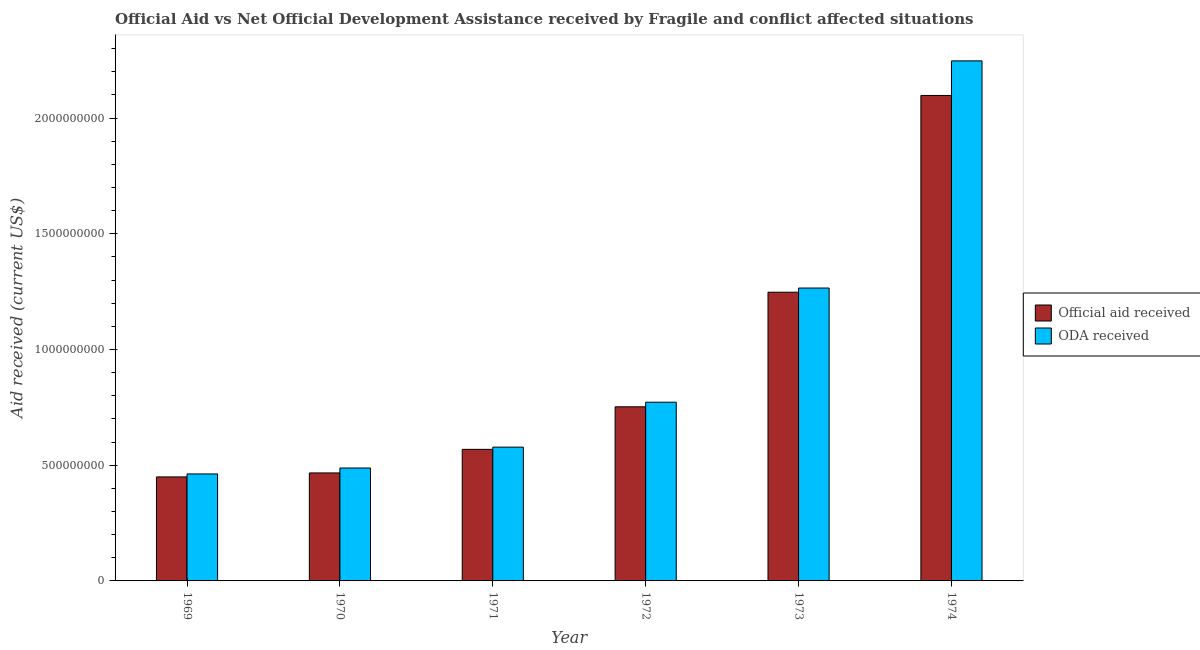Are the number of bars on each tick of the X-axis equal?
Offer a very short reply. Yes. How many bars are there on the 2nd tick from the left?
Make the answer very short. 2. What is the oda received in 1972?
Offer a very short reply. 7.72e+08. Across all years, what is the maximum oda received?
Ensure brevity in your answer.  2.25e+09. Across all years, what is the minimum official aid received?
Provide a succinct answer. 4.49e+08. In which year was the official aid received maximum?
Your response must be concise. 1974. In which year was the oda received minimum?
Offer a very short reply. 1969. What is the total oda received in the graph?
Give a very brief answer. 5.81e+09. What is the difference between the official aid received in 1969 and that in 1973?
Your response must be concise. -7.98e+08. What is the difference between the oda received in 1971 and the official aid received in 1972?
Your response must be concise. -1.94e+08. What is the average oda received per year?
Keep it short and to the point. 9.69e+08. In the year 1973, what is the difference between the official aid received and oda received?
Offer a terse response. 0. In how many years, is the oda received greater than 800000000 US$?
Provide a short and direct response. 2. What is the ratio of the oda received in 1969 to that in 1974?
Your response must be concise. 0.21. Is the official aid received in 1969 less than that in 1973?
Provide a short and direct response. Yes. Is the difference between the official aid received in 1970 and 1971 greater than the difference between the oda received in 1970 and 1971?
Provide a short and direct response. No. What is the difference between the highest and the second highest oda received?
Your response must be concise. 9.81e+08. What is the difference between the highest and the lowest official aid received?
Provide a succinct answer. 1.65e+09. Is the sum of the oda received in 1971 and 1973 greater than the maximum official aid received across all years?
Make the answer very short. No. What does the 1st bar from the left in 1974 represents?
Your answer should be compact. Official aid received. What does the 2nd bar from the right in 1969 represents?
Offer a terse response. Official aid received. Are all the bars in the graph horizontal?
Ensure brevity in your answer.  No. What is the difference between two consecutive major ticks on the Y-axis?
Offer a very short reply. 5.00e+08. Does the graph contain any zero values?
Keep it short and to the point. No. Does the graph contain grids?
Ensure brevity in your answer.  No. How are the legend labels stacked?
Your response must be concise. Vertical. What is the title of the graph?
Your answer should be compact. Official Aid vs Net Official Development Assistance received by Fragile and conflict affected situations . What is the label or title of the X-axis?
Make the answer very short. Year. What is the label or title of the Y-axis?
Offer a very short reply. Aid received (current US$). What is the Aid received (current US$) in Official aid received in 1969?
Offer a terse response. 4.49e+08. What is the Aid received (current US$) of ODA received in 1969?
Provide a succinct answer. 4.62e+08. What is the Aid received (current US$) of Official aid received in 1970?
Offer a very short reply. 4.67e+08. What is the Aid received (current US$) of ODA received in 1970?
Ensure brevity in your answer.  4.88e+08. What is the Aid received (current US$) of Official aid received in 1971?
Give a very brief answer. 5.68e+08. What is the Aid received (current US$) in ODA received in 1971?
Offer a terse response. 5.78e+08. What is the Aid received (current US$) in Official aid received in 1972?
Keep it short and to the point. 7.52e+08. What is the Aid received (current US$) of ODA received in 1972?
Your answer should be very brief. 7.72e+08. What is the Aid received (current US$) of Official aid received in 1973?
Keep it short and to the point. 1.25e+09. What is the Aid received (current US$) of ODA received in 1973?
Provide a short and direct response. 1.27e+09. What is the Aid received (current US$) of Official aid received in 1974?
Provide a succinct answer. 2.10e+09. What is the Aid received (current US$) in ODA received in 1974?
Your answer should be very brief. 2.25e+09. Across all years, what is the maximum Aid received (current US$) of Official aid received?
Give a very brief answer. 2.10e+09. Across all years, what is the maximum Aid received (current US$) in ODA received?
Ensure brevity in your answer.  2.25e+09. Across all years, what is the minimum Aid received (current US$) in Official aid received?
Give a very brief answer. 4.49e+08. Across all years, what is the minimum Aid received (current US$) in ODA received?
Provide a succinct answer. 4.62e+08. What is the total Aid received (current US$) in Official aid received in the graph?
Ensure brevity in your answer.  5.58e+09. What is the total Aid received (current US$) in ODA received in the graph?
Your answer should be very brief. 5.81e+09. What is the difference between the Aid received (current US$) in Official aid received in 1969 and that in 1970?
Your response must be concise. -1.72e+07. What is the difference between the Aid received (current US$) in ODA received in 1969 and that in 1970?
Your answer should be very brief. -2.56e+07. What is the difference between the Aid received (current US$) in Official aid received in 1969 and that in 1971?
Offer a terse response. -1.19e+08. What is the difference between the Aid received (current US$) of ODA received in 1969 and that in 1971?
Your answer should be compact. -1.16e+08. What is the difference between the Aid received (current US$) in Official aid received in 1969 and that in 1972?
Your response must be concise. -3.03e+08. What is the difference between the Aid received (current US$) of ODA received in 1969 and that in 1972?
Make the answer very short. -3.10e+08. What is the difference between the Aid received (current US$) of Official aid received in 1969 and that in 1973?
Offer a terse response. -7.98e+08. What is the difference between the Aid received (current US$) in ODA received in 1969 and that in 1973?
Give a very brief answer. -8.03e+08. What is the difference between the Aid received (current US$) in Official aid received in 1969 and that in 1974?
Make the answer very short. -1.65e+09. What is the difference between the Aid received (current US$) in ODA received in 1969 and that in 1974?
Make the answer very short. -1.78e+09. What is the difference between the Aid received (current US$) of Official aid received in 1970 and that in 1971?
Offer a terse response. -1.02e+08. What is the difference between the Aid received (current US$) of ODA received in 1970 and that in 1971?
Your answer should be compact. -9.02e+07. What is the difference between the Aid received (current US$) of Official aid received in 1970 and that in 1972?
Your answer should be compact. -2.86e+08. What is the difference between the Aid received (current US$) in ODA received in 1970 and that in 1972?
Your answer should be very brief. -2.84e+08. What is the difference between the Aid received (current US$) in Official aid received in 1970 and that in 1973?
Offer a terse response. -7.81e+08. What is the difference between the Aid received (current US$) in ODA received in 1970 and that in 1973?
Your answer should be compact. -7.78e+08. What is the difference between the Aid received (current US$) of Official aid received in 1970 and that in 1974?
Your answer should be compact. -1.63e+09. What is the difference between the Aid received (current US$) in ODA received in 1970 and that in 1974?
Provide a short and direct response. -1.76e+09. What is the difference between the Aid received (current US$) of Official aid received in 1971 and that in 1972?
Give a very brief answer. -1.84e+08. What is the difference between the Aid received (current US$) of ODA received in 1971 and that in 1972?
Make the answer very short. -1.94e+08. What is the difference between the Aid received (current US$) in Official aid received in 1971 and that in 1973?
Give a very brief answer. -6.79e+08. What is the difference between the Aid received (current US$) in ODA received in 1971 and that in 1973?
Your answer should be very brief. -6.87e+08. What is the difference between the Aid received (current US$) in Official aid received in 1971 and that in 1974?
Your answer should be very brief. -1.53e+09. What is the difference between the Aid received (current US$) of ODA received in 1971 and that in 1974?
Ensure brevity in your answer.  -1.67e+09. What is the difference between the Aid received (current US$) in Official aid received in 1972 and that in 1973?
Ensure brevity in your answer.  -4.95e+08. What is the difference between the Aid received (current US$) of ODA received in 1972 and that in 1973?
Your answer should be very brief. -4.93e+08. What is the difference between the Aid received (current US$) in Official aid received in 1972 and that in 1974?
Keep it short and to the point. -1.35e+09. What is the difference between the Aid received (current US$) of ODA received in 1972 and that in 1974?
Offer a terse response. -1.47e+09. What is the difference between the Aid received (current US$) of Official aid received in 1973 and that in 1974?
Provide a succinct answer. -8.50e+08. What is the difference between the Aid received (current US$) in ODA received in 1973 and that in 1974?
Keep it short and to the point. -9.81e+08. What is the difference between the Aid received (current US$) of Official aid received in 1969 and the Aid received (current US$) of ODA received in 1970?
Offer a very short reply. -3.85e+07. What is the difference between the Aid received (current US$) of Official aid received in 1969 and the Aid received (current US$) of ODA received in 1971?
Offer a very short reply. -1.29e+08. What is the difference between the Aid received (current US$) of Official aid received in 1969 and the Aid received (current US$) of ODA received in 1972?
Provide a succinct answer. -3.23e+08. What is the difference between the Aid received (current US$) in Official aid received in 1969 and the Aid received (current US$) in ODA received in 1973?
Make the answer very short. -8.16e+08. What is the difference between the Aid received (current US$) in Official aid received in 1969 and the Aid received (current US$) in ODA received in 1974?
Ensure brevity in your answer.  -1.80e+09. What is the difference between the Aid received (current US$) of Official aid received in 1970 and the Aid received (current US$) of ODA received in 1971?
Offer a very short reply. -1.11e+08. What is the difference between the Aid received (current US$) of Official aid received in 1970 and the Aid received (current US$) of ODA received in 1972?
Ensure brevity in your answer.  -3.06e+08. What is the difference between the Aid received (current US$) in Official aid received in 1970 and the Aid received (current US$) in ODA received in 1973?
Ensure brevity in your answer.  -7.99e+08. What is the difference between the Aid received (current US$) in Official aid received in 1970 and the Aid received (current US$) in ODA received in 1974?
Your answer should be very brief. -1.78e+09. What is the difference between the Aid received (current US$) of Official aid received in 1971 and the Aid received (current US$) of ODA received in 1972?
Your answer should be compact. -2.04e+08. What is the difference between the Aid received (current US$) of Official aid received in 1971 and the Aid received (current US$) of ODA received in 1973?
Give a very brief answer. -6.97e+08. What is the difference between the Aid received (current US$) in Official aid received in 1971 and the Aid received (current US$) in ODA received in 1974?
Offer a terse response. -1.68e+09. What is the difference between the Aid received (current US$) of Official aid received in 1972 and the Aid received (current US$) of ODA received in 1973?
Offer a very short reply. -5.13e+08. What is the difference between the Aid received (current US$) of Official aid received in 1972 and the Aid received (current US$) of ODA received in 1974?
Your answer should be very brief. -1.49e+09. What is the difference between the Aid received (current US$) in Official aid received in 1973 and the Aid received (current US$) in ODA received in 1974?
Keep it short and to the point. -9.99e+08. What is the average Aid received (current US$) of Official aid received per year?
Give a very brief answer. 9.30e+08. What is the average Aid received (current US$) of ODA received per year?
Your response must be concise. 9.69e+08. In the year 1969, what is the difference between the Aid received (current US$) of Official aid received and Aid received (current US$) of ODA received?
Ensure brevity in your answer.  -1.29e+07. In the year 1970, what is the difference between the Aid received (current US$) in Official aid received and Aid received (current US$) in ODA received?
Give a very brief answer. -2.13e+07. In the year 1971, what is the difference between the Aid received (current US$) in Official aid received and Aid received (current US$) in ODA received?
Give a very brief answer. -9.60e+06. In the year 1972, what is the difference between the Aid received (current US$) in Official aid received and Aid received (current US$) in ODA received?
Your answer should be very brief. -1.99e+07. In the year 1973, what is the difference between the Aid received (current US$) of Official aid received and Aid received (current US$) of ODA received?
Your response must be concise. -1.81e+07. In the year 1974, what is the difference between the Aid received (current US$) of Official aid received and Aid received (current US$) of ODA received?
Offer a terse response. -1.49e+08. What is the ratio of the Aid received (current US$) of Official aid received in 1969 to that in 1970?
Ensure brevity in your answer.  0.96. What is the ratio of the Aid received (current US$) of ODA received in 1969 to that in 1970?
Give a very brief answer. 0.95. What is the ratio of the Aid received (current US$) of Official aid received in 1969 to that in 1971?
Offer a terse response. 0.79. What is the ratio of the Aid received (current US$) in ODA received in 1969 to that in 1971?
Your answer should be very brief. 0.8. What is the ratio of the Aid received (current US$) in Official aid received in 1969 to that in 1972?
Your answer should be very brief. 0.6. What is the ratio of the Aid received (current US$) in ODA received in 1969 to that in 1972?
Your response must be concise. 0.6. What is the ratio of the Aid received (current US$) of Official aid received in 1969 to that in 1973?
Offer a very short reply. 0.36. What is the ratio of the Aid received (current US$) in ODA received in 1969 to that in 1973?
Your answer should be very brief. 0.37. What is the ratio of the Aid received (current US$) in Official aid received in 1969 to that in 1974?
Give a very brief answer. 0.21. What is the ratio of the Aid received (current US$) of ODA received in 1969 to that in 1974?
Keep it short and to the point. 0.21. What is the ratio of the Aid received (current US$) in Official aid received in 1970 to that in 1971?
Offer a very short reply. 0.82. What is the ratio of the Aid received (current US$) of ODA received in 1970 to that in 1971?
Provide a succinct answer. 0.84. What is the ratio of the Aid received (current US$) of Official aid received in 1970 to that in 1972?
Your answer should be compact. 0.62. What is the ratio of the Aid received (current US$) in ODA received in 1970 to that in 1972?
Offer a very short reply. 0.63. What is the ratio of the Aid received (current US$) of Official aid received in 1970 to that in 1973?
Give a very brief answer. 0.37. What is the ratio of the Aid received (current US$) of ODA received in 1970 to that in 1973?
Your answer should be very brief. 0.39. What is the ratio of the Aid received (current US$) of Official aid received in 1970 to that in 1974?
Offer a terse response. 0.22. What is the ratio of the Aid received (current US$) in ODA received in 1970 to that in 1974?
Keep it short and to the point. 0.22. What is the ratio of the Aid received (current US$) in Official aid received in 1971 to that in 1972?
Provide a short and direct response. 0.76. What is the ratio of the Aid received (current US$) in ODA received in 1971 to that in 1972?
Your answer should be compact. 0.75. What is the ratio of the Aid received (current US$) in Official aid received in 1971 to that in 1973?
Give a very brief answer. 0.46. What is the ratio of the Aid received (current US$) of ODA received in 1971 to that in 1973?
Your answer should be very brief. 0.46. What is the ratio of the Aid received (current US$) in Official aid received in 1971 to that in 1974?
Keep it short and to the point. 0.27. What is the ratio of the Aid received (current US$) of ODA received in 1971 to that in 1974?
Your answer should be very brief. 0.26. What is the ratio of the Aid received (current US$) in Official aid received in 1972 to that in 1973?
Offer a very short reply. 0.6. What is the ratio of the Aid received (current US$) in ODA received in 1972 to that in 1973?
Offer a very short reply. 0.61. What is the ratio of the Aid received (current US$) in Official aid received in 1972 to that in 1974?
Provide a succinct answer. 0.36. What is the ratio of the Aid received (current US$) of ODA received in 1972 to that in 1974?
Offer a terse response. 0.34. What is the ratio of the Aid received (current US$) in Official aid received in 1973 to that in 1974?
Ensure brevity in your answer.  0.59. What is the ratio of the Aid received (current US$) of ODA received in 1973 to that in 1974?
Keep it short and to the point. 0.56. What is the difference between the highest and the second highest Aid received (current US$) in Official aid received?
Ensure brevity in your answer.  8.50e+08. What is the difference between the highest and the second highest Aid received (current US$) in ODA received?
Give a very brief answer. 9.81e+08. What is the difference between the highest and the lowest Aid received (current US$) of Official aid received?
Give a very brief answer. 1.65e+09. What is the difference between the highest and the lowest Aid received (current US$) in ODA received?
Your answer should be very brief. 1.78e+09. 